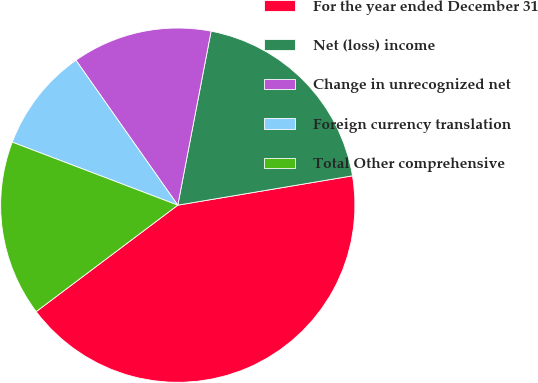Convert chart. <chart><loc_0><loc_0><loc_500><loc_500><pie_chart><fcel>For the year ended December 31<fcel>Net (loss) income<fcel>Change in unrecognized net<fcel>Foreign currency translation<fcel>Total Other comprehensive<nl><fcel>42.39%<fcel>19.34%<fcel>12.76%<fcel>9.46%<fcel>16.05%<nl></chart> 